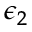<formula> <loc_0><loc_0><loc_500><loc_500>\epsilon _ { 2 }</formula> 